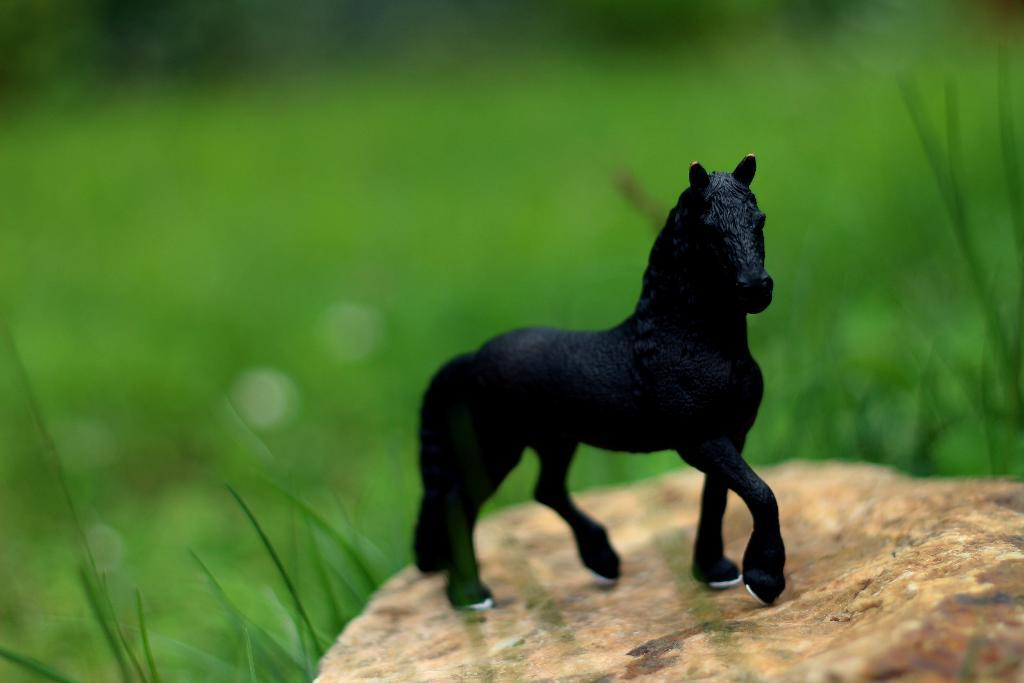What object can be seen in the image? There is a toy in the image. Where is the toy located? The toy is on a surface. Can you describe the background of the image? The background of the image is blurred. What type of natural environment is visible in the background? There is greenery visible in the background of the image. What historical event is depicted in the background of the image? There is no historical event depicted in the background of the image; it features greenery. What type of fruit can be seen hanging from the toy in the image? There is no fruit present in the image, and the toy does not have any fruit hanging from it. 